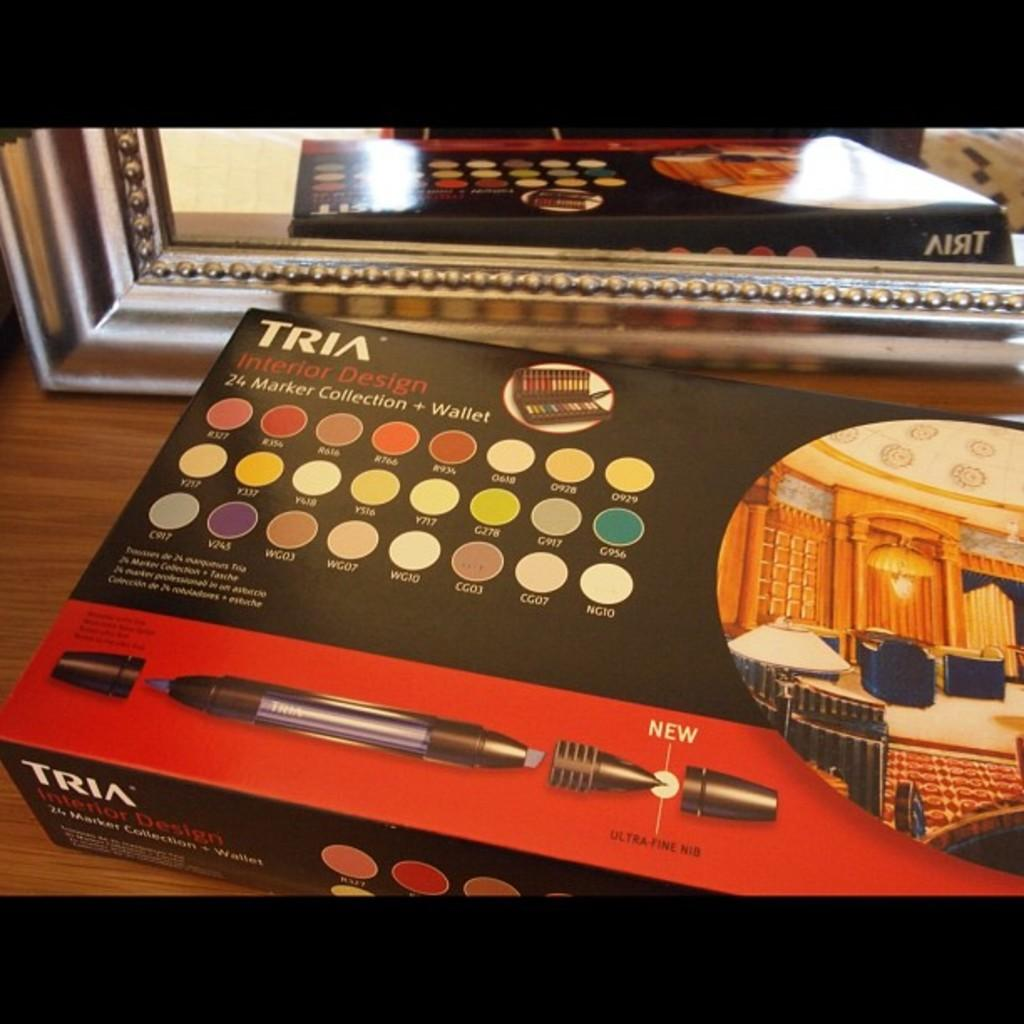<image>
Present a compact description of the photo's key features. A Tria box with Interior Design Markers sits on a shelf. 